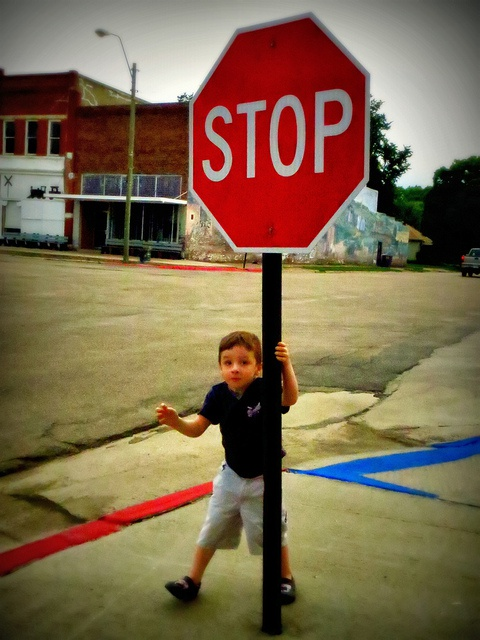Describe the objects in this image and their specific colors. I can see stop sign in black, maroon, darkgray, and brown tones, people in black, maroon, gray, and tan tones, and car in black and gray tones in this image. 